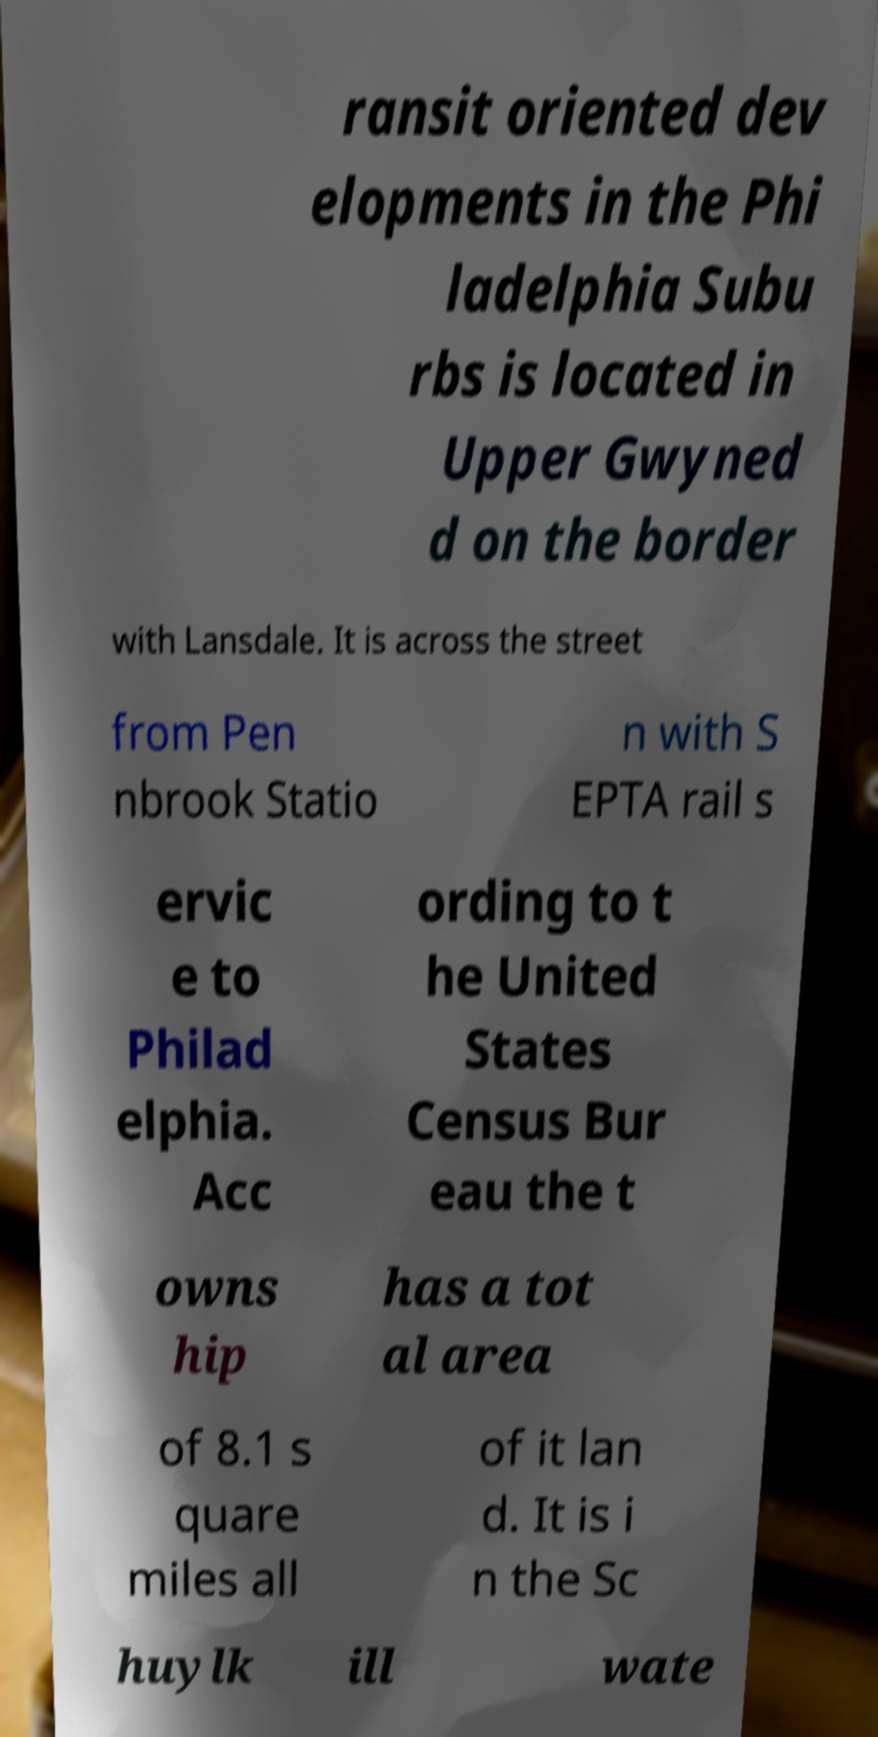Can you read and provide the text displayed in the image?This photo seems to have some interesting text. Can you extract and type it out for me? ransit oriented dev elopments in the Phi ladelphia Subu rbs is located in Upper Gwyned d on the border with Lansdale. It is across the street from Pen nbrook Statio n with S EPTA rail s ervic e to Philad elphia. Acc ording to t he United States Census Bur eau the t owns hip has a tot al area of 8.1 s quare miles all of it lan d. It is i n the Sc huylk ill wate 